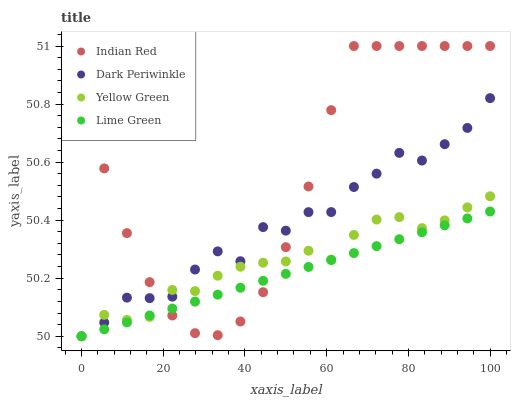Does Lime Green have the minimum area under the curve?
Answer yes or no. Yes. Does Indian Red have the maximum area under the curve?
Answer yes or no. Yes. Does Dark Periwinkle have the minimum area under the curve?
Answer yes or no. No. Does Dark Periwinkle have the maximum area under the curve?
Answer yes or no. No. Is Lime Green the smoothest?
Answer yes or no. Yes. Is Dark Periwinkle the roughest?
Answer yes or no. Yes. Is Indian Red the smoothest?
Answer yes or no. No. Is Indian Red the roughest?
Answer yes or no. No. Does Lime Green have the lowest value?
Answer yes or no. Yes. Does Indian Red have the lowest value?
Answer yes or no. No. Does Indian Red have the highest value?
Answer yes or no. Yes. Does Dark Periwinkle have the highest value?
Answer yes or no. No. Does Yellow Green intersect Indian Red?
Answer yes or no. Yes. Is Yellow Green less than Indian Red?
Answer yes or no. No. Is Yellow Green greater than Indian Red?
Answer yes or no. No. 